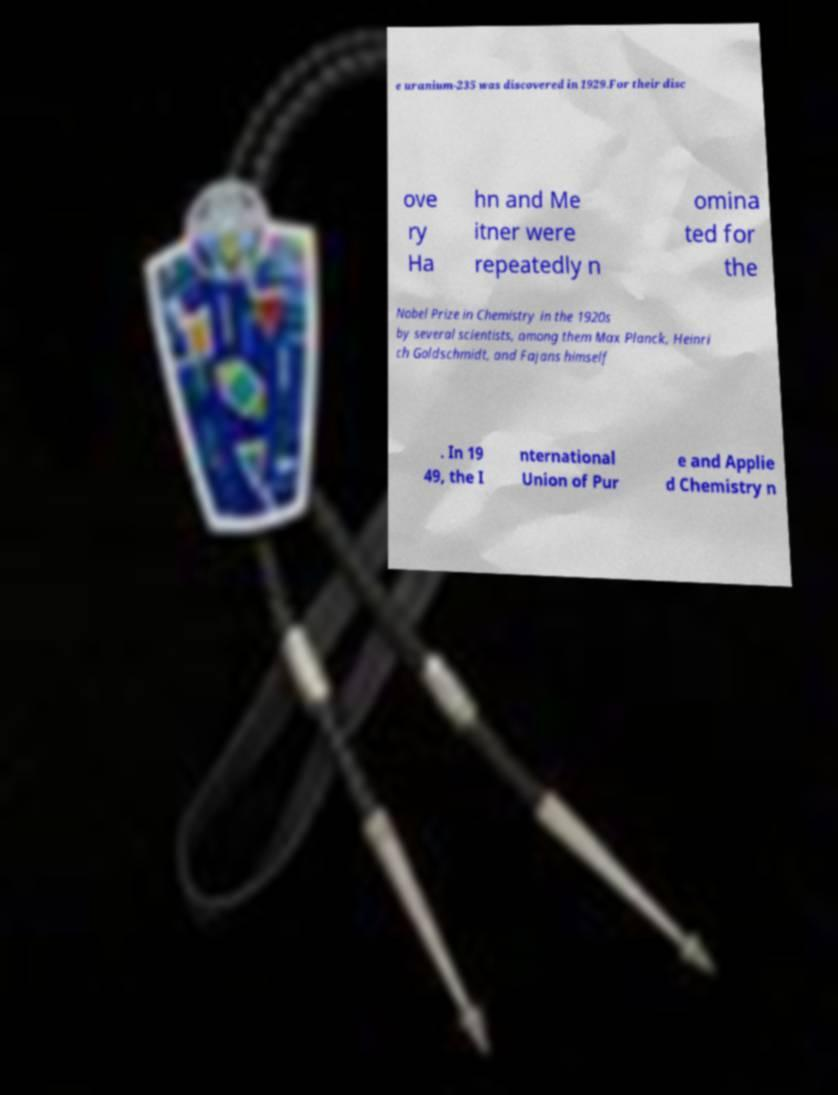Please identify and transcribe the text found in this image. e uranium-235 was discovered in 1929.For their disc ove ry Ha hn and Me itner were repeatedly n omina ted for the Nobel Prize in Chemistry in the 1920s by several scientists, among them Max Planck, Heinri ch Goldschmidt, and Fajans himself . In 19 49, the I nternational Union of Pur e and Applie d Chemistry n 